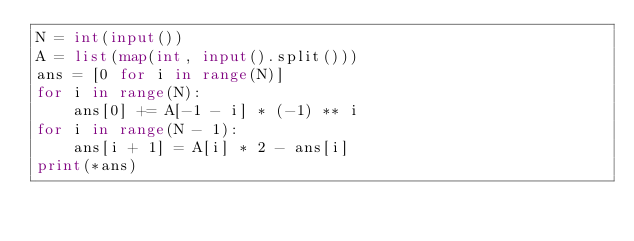<code> <loc_0><loc_0><loc_500><loc_500><_Python_>N = int(input())
A = list(map(int, input().split()))
ans = [0 for i in range(N)]
for i in range(N):
    ans[0] += A[-1 - i] * (-1) ** i
for i in range(N - 1):
    ans[i + 1] = A[i] * 2 - ans[i]
print(*ans)
</code> 